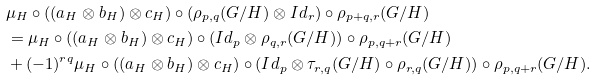<formula> <loc_0><loc_0><loc_500><loc_500>& \mu _ { H } \circ ( ( a _ { H } \otimes b _ { H } ) \otimes c _ { H } ) \circ ( \rho _ { p , q } ( G / H ) \otimes I d _ { r } ) \circ \rho _ { p + q , r } ( G / H ) \\ & = \mu _ { H } \circ ( ( a _ { H } \otimes b _ { H } ) \otimes c _ { H } ) \circ ( I d _ { p } \otimes \rho _ { q , r } ( G / H ) ) \circ \rho _ { p , q + r } ( G / H ) \\ & + ( - 1 ) ^ { r q } \mu _ { H } \circ ( ( a _ { H } \otimes b _ { H } ) \otimes c _ { H } ) \circ ( I d _ { p } \otimes \tau _ { r , q } ( G / H ) \circ \rho _ { r , q } ( G / H ) ) \circ \rho _ { p , q + r } ( G / H ) .</formula> 